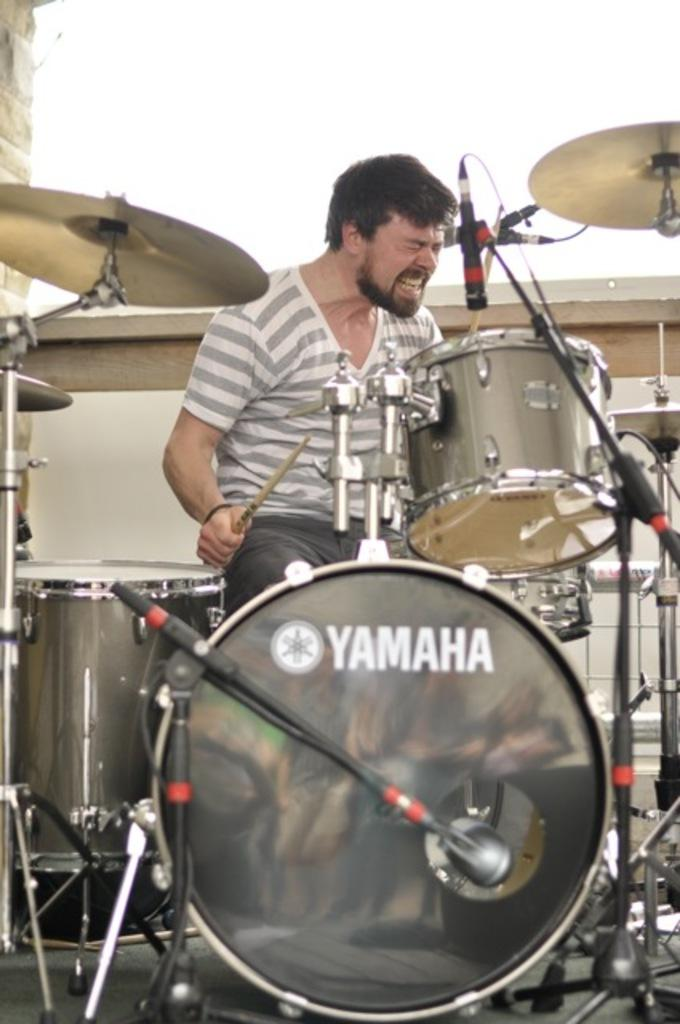What is the person holding in the image? The person is holding a stick. What objects are in front of the person? There are musical drums, plates, and microphones in front of the person. What might the person be using the stick for? The person might be using the stick to play the musical drums. What could the plates be used for? The plates could be used for serving food or holding items during the performance. What type of account does the person need to open to access the view in the image? There is no mention of an account or view in the image; it features a person holding a stick with musical drums, plates, and microphones in front of them. 